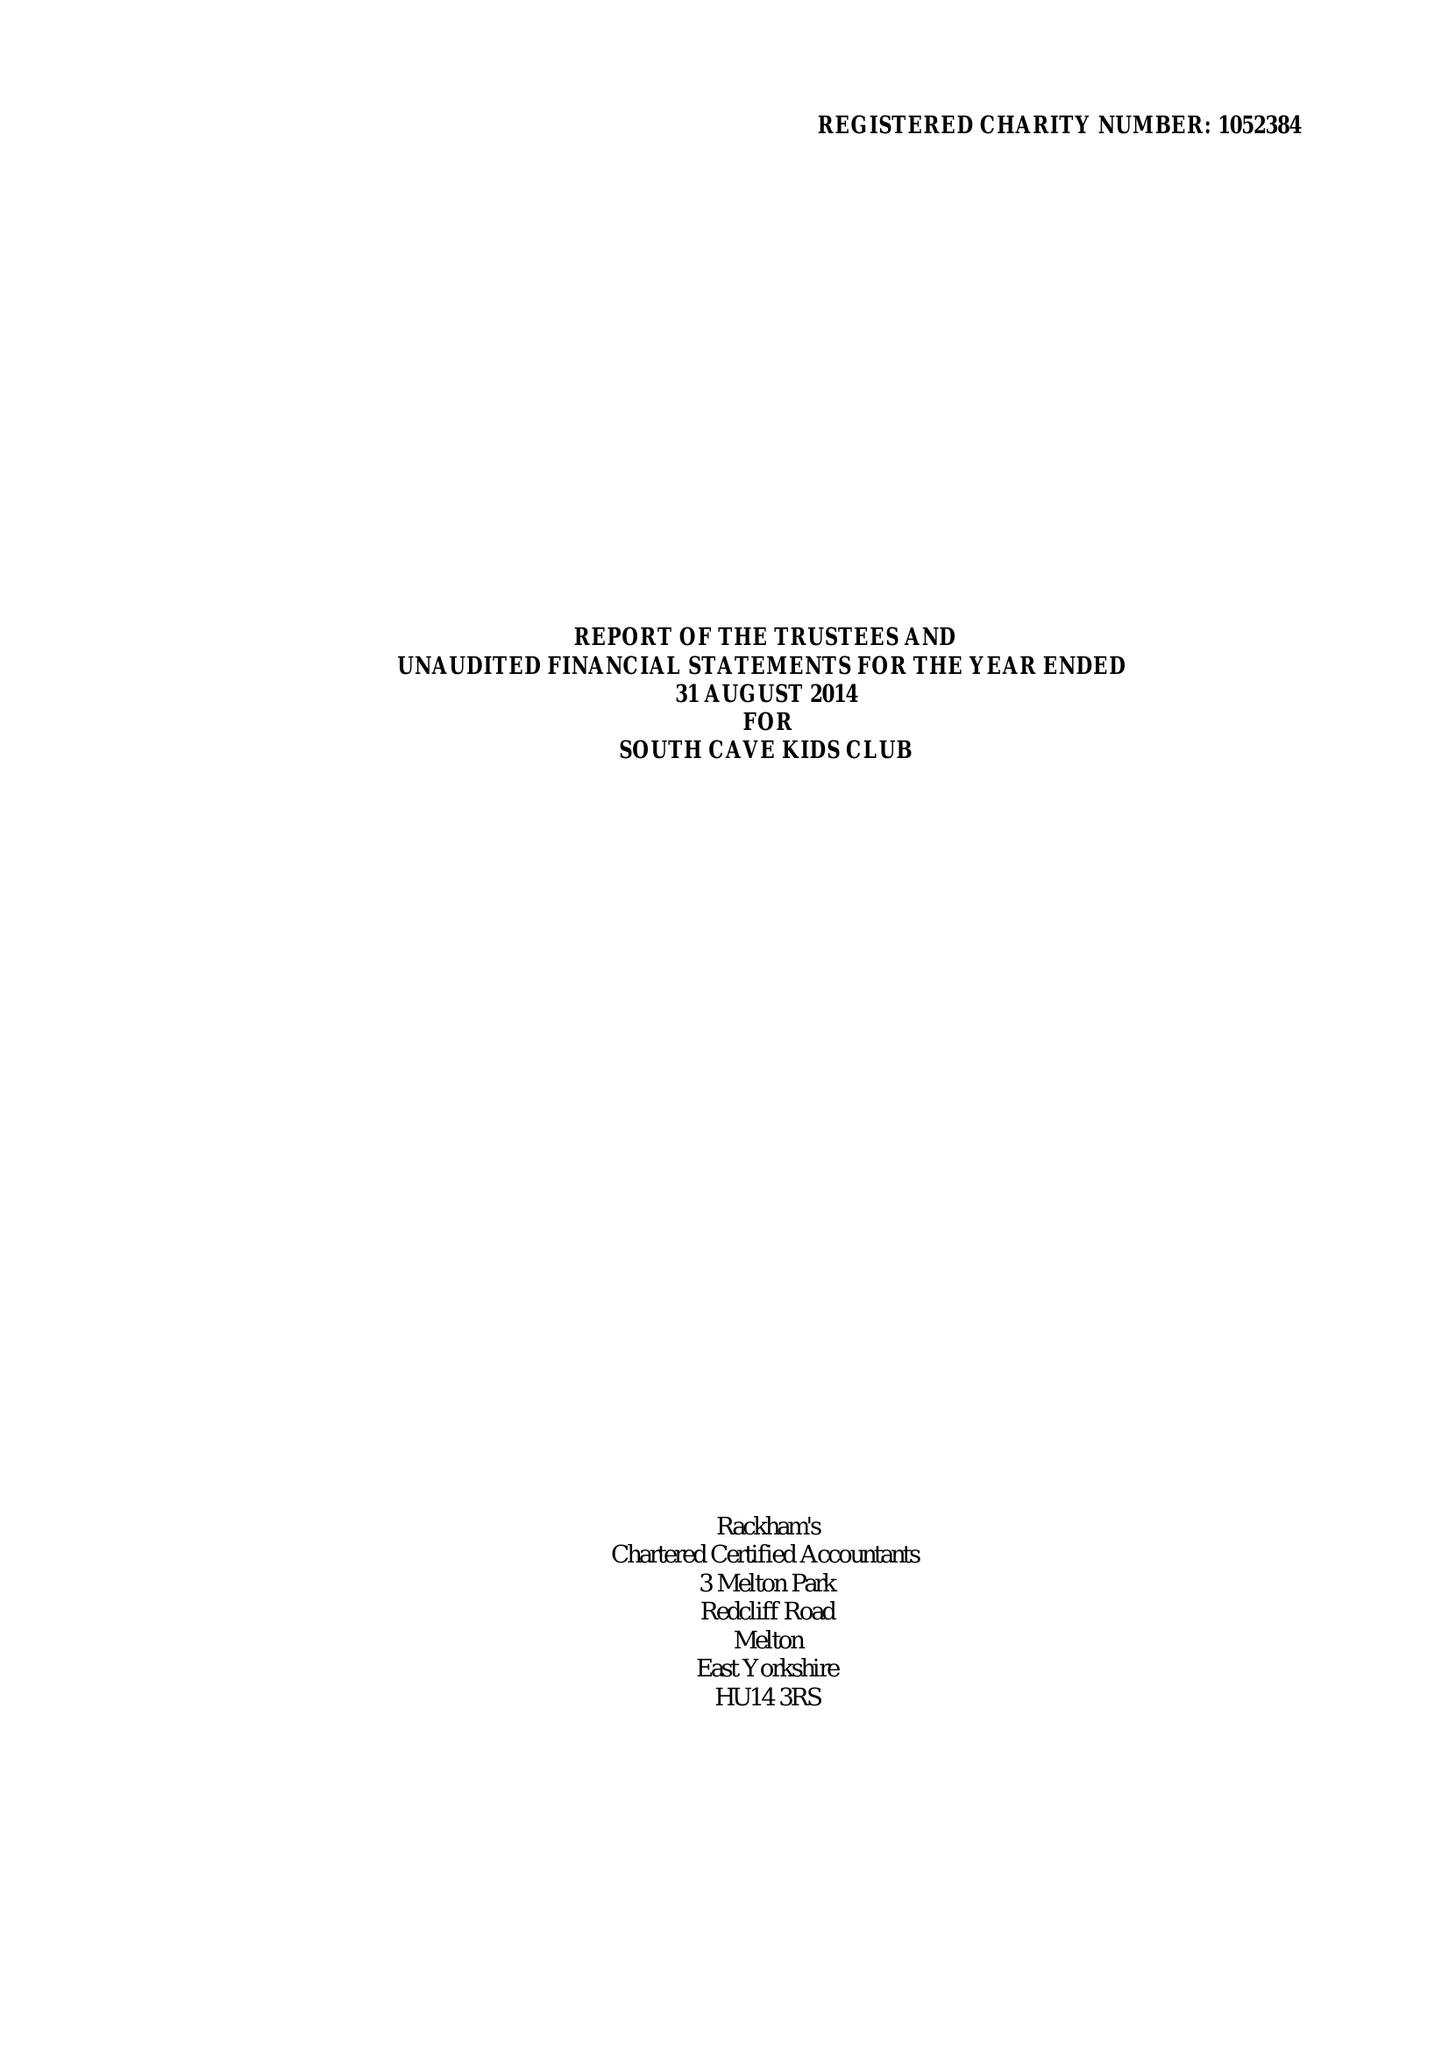What is the value for the address__post_town?
Answer the question using a single word or phrase. BROUGH 